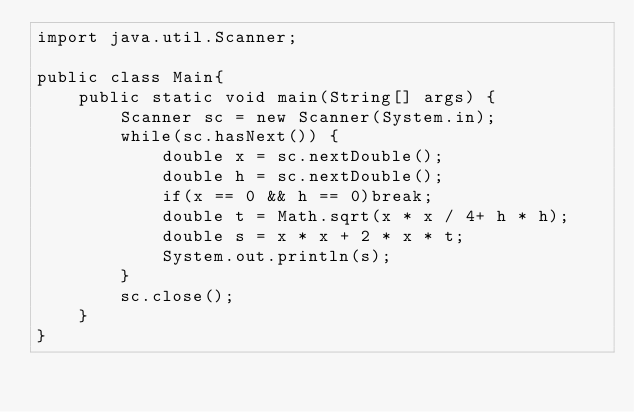Convert code to text. <code><loc_0><loc_0><loc_500><loc_500><_Java_>import java.util.Scanner;

public class Main{
	public static void main(String[] args) {
		Scanner sc = new Scanner(System.in);
		while(sc.hasNext()) {
			double x = sc.nextDouble();
			double h = sc.nextDouble();
			if(x == 0 && h == 0)break;
			double t = Math.sqrt(x * x / 4+ h * h);
			double s = x * x + 2 * x * t;
			System.out.println(s);
		}
		sc.close();
	}
}
</code> 